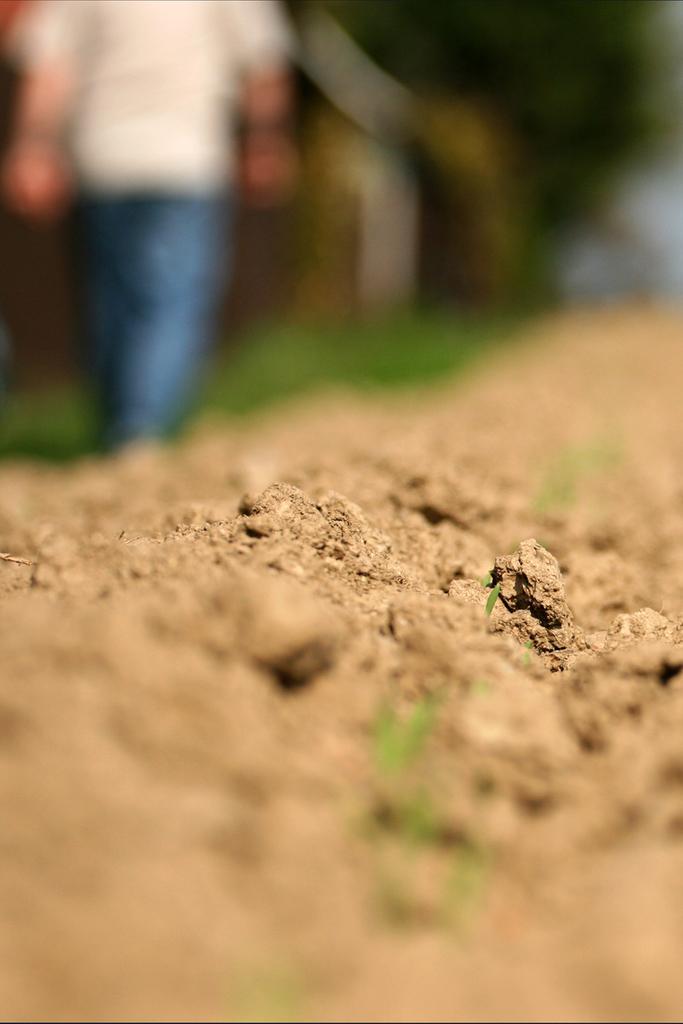Please provide a concise description of this image. In this image there is sand , and there is blur background. 